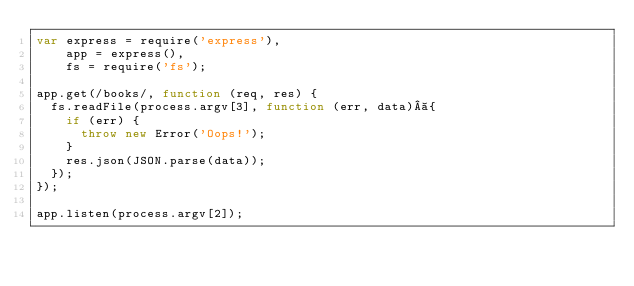<code> <loc_0><loc_0><loc_500><loc_500><_JavaScript_>var express = require('express'),
    app = express(),
    fs = require('fs');

app.get(/books/, function (req, res) {
  fs.readFile(process.argv[3], function (err, data) {
    if (err) {
      throw new Error('Oops!');
    }
    res.json(JSON.parse(data));
  });
});

app.listen(process.argv[2]);
</code> 